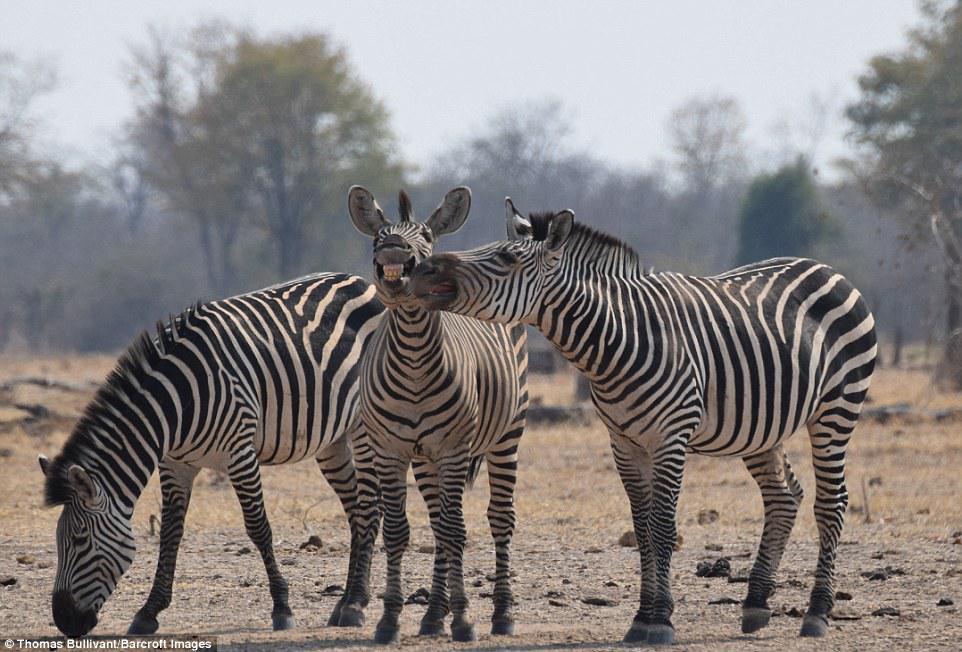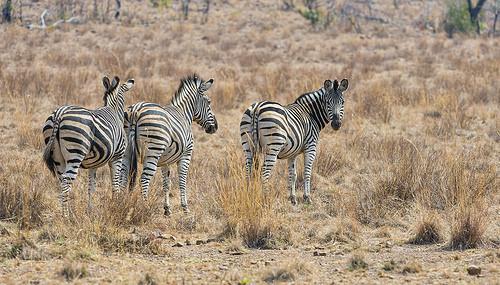The first image is the image on the left, the second image is the image on the right. For the images displayed, is the sentence "Each image contains exactly three zebras, and one group of three zebras is turned away from the camera, with their rears showing." factually correct? Answer yes or no. Yes. 